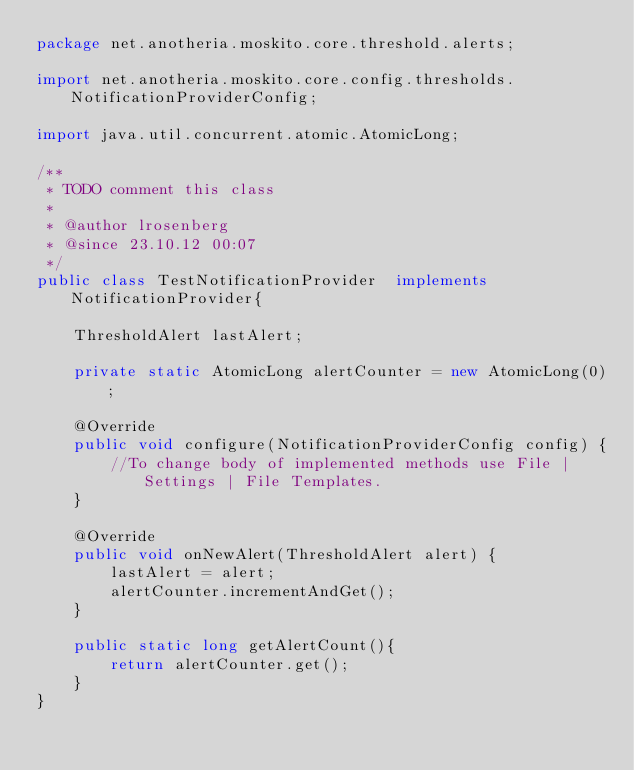Convert code to text. <code><loc_0><loc_0><loc_500><loc_500><_Java_>package net.anotheria.moskito.core.threshold.alerts;

import net.anotheria.moskito.core.config.thresholds.NotificationProviderConfig;

import java.util.concurrent.atomic.AtomicLong;

/**
 * TODO comment this class
 *
 * @author lrosenberg
 * @since 23.10.12 00:07
 */
public class TestNotificationProvider  implements NotificationProvider{

	ThresholdAlert lastAlert;

	private static AtomicLong alertCounter = new AtomicLong(0);

	@Override
	public void configure(NotificationProviderConfig config) {
		//To change body of implemented methods use File | Settings | File Templates.
	}

	@Override
	public void onNewAlert(ThresholdAlert alert) {
		lastAlert = alert;
		alertCounter.incrementAndGet();
	}

	public static long getAlertCount(){
		return alertCounter.get();
	}
}

</code> 